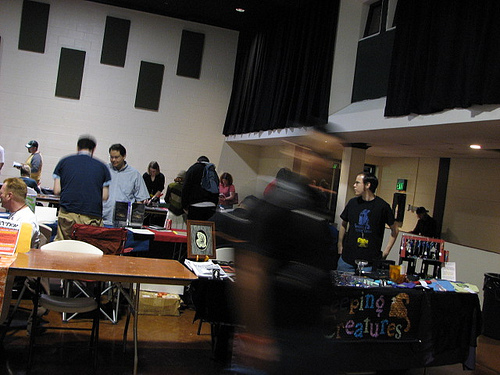<image>
Can you confirm if the man is in front of the table? Yes. The man is positioned in front of the table, appearing closer to the camera viewpoint. 